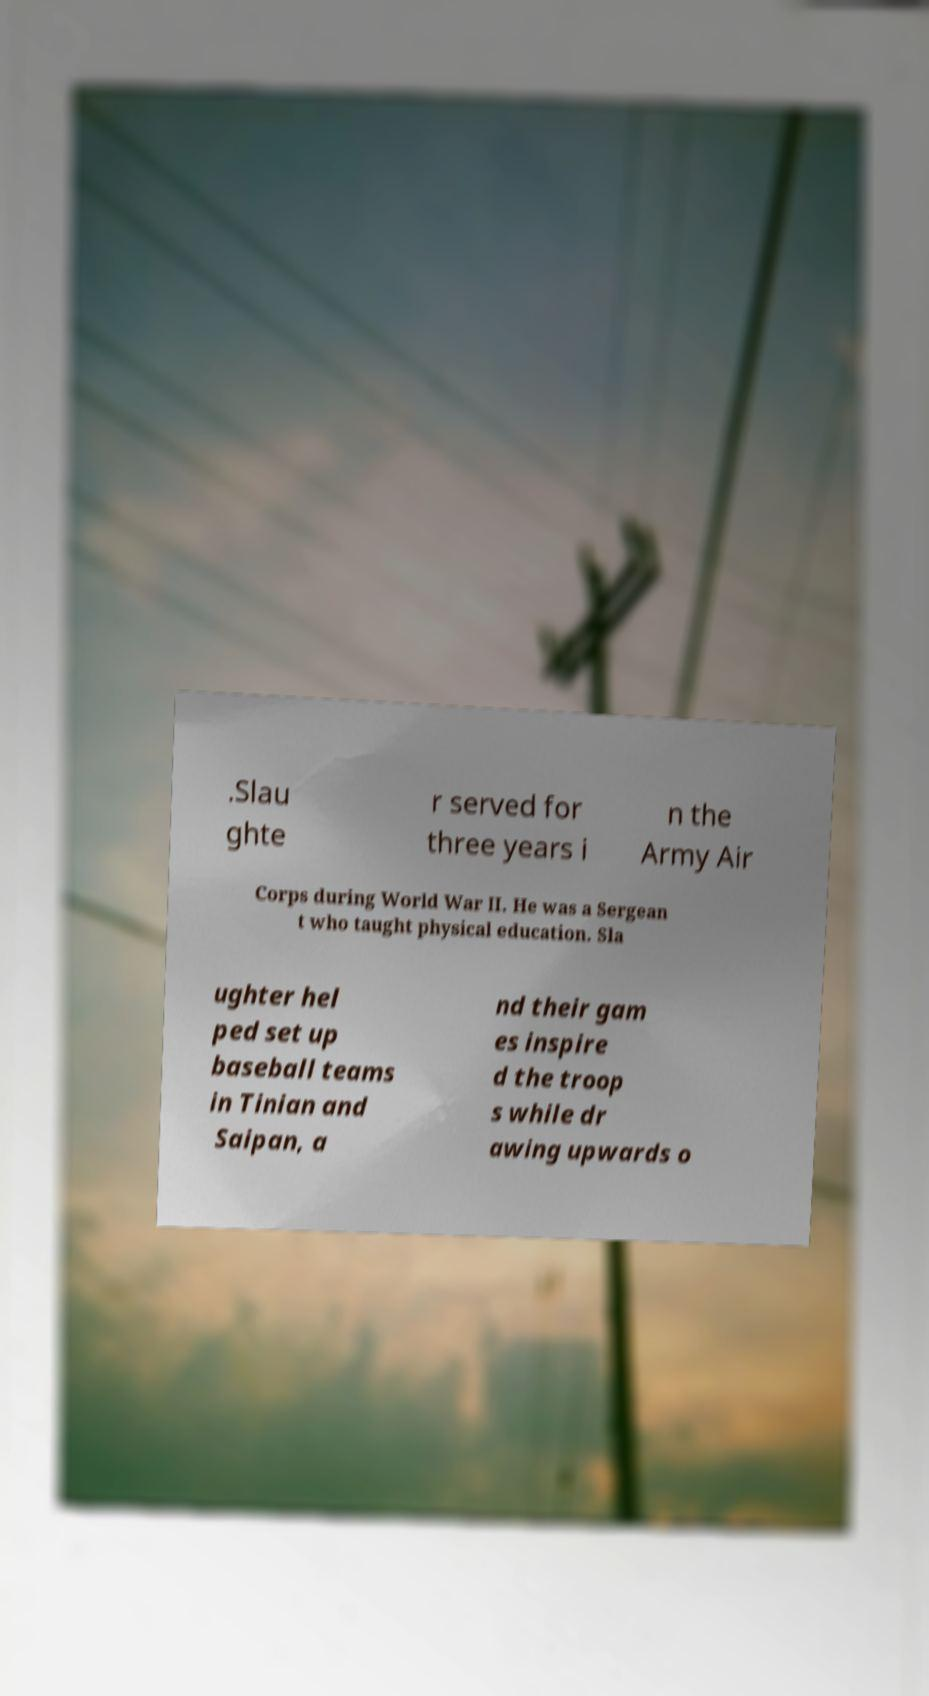Could you assist in decoding the text presented in this image and type it out clearly? .Slau ghte r served for three years i n the Army Air Corps during World War II. He was a Sergean t who taught physical education. Sla ughter hel ped set up baseball teams in Tinian and Saipan, a nd their gam es inspire d the troop s while dr awing upwards o 